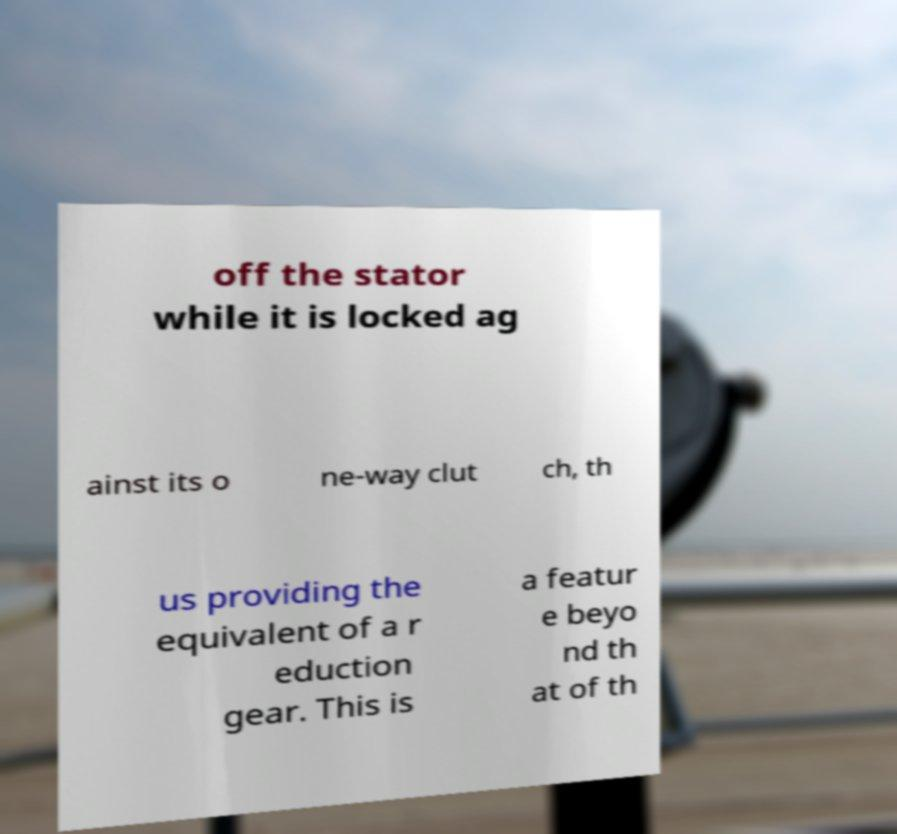What messages or text are displayed in this image? I need them in a readable, typed format. off the stator while it is locked ag ainst its o ne-way clut ch, th us providing the equivalent of a r eduction gear. This is a featur e beyo nd th at of th 